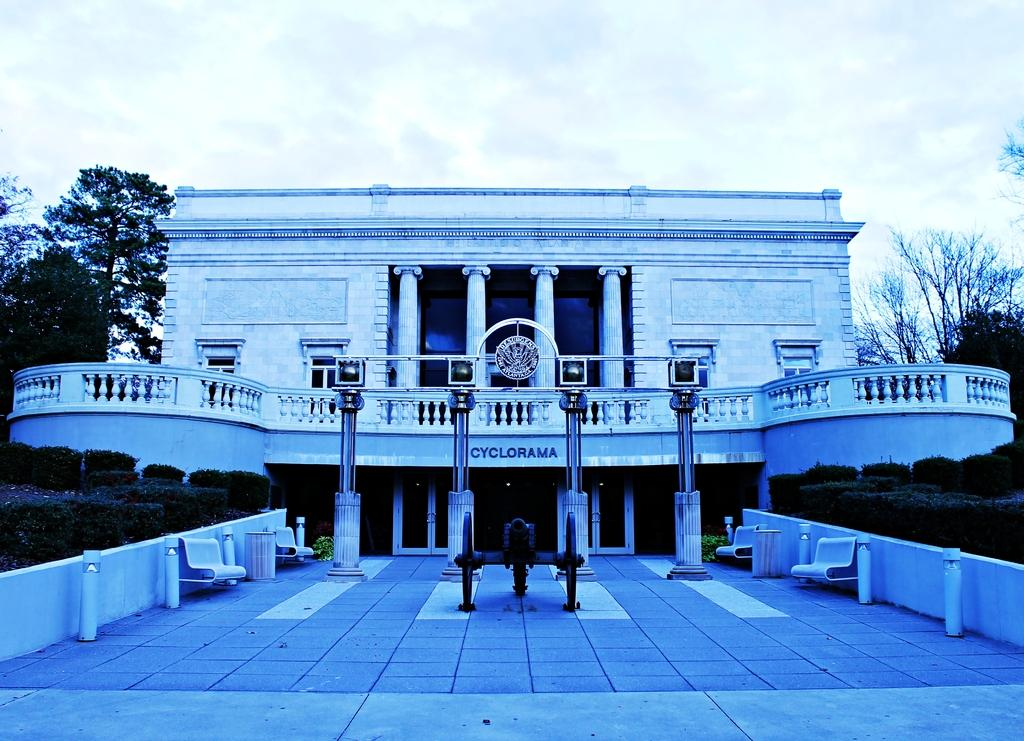What is the main subject of the image? The main subject of the image is a building at the center. What can be seen on the sides of the building? There are plants on both the right and left sides of the image. What type of vegetation is visible in the background? There are trees visible at the back of the image. What is visible in the background of the image? The sky is visible in the background of the image. What type of board is being used for treatment in the image? There is no board or treatment present in the image; it features a building, plants, trees, and the sky. 